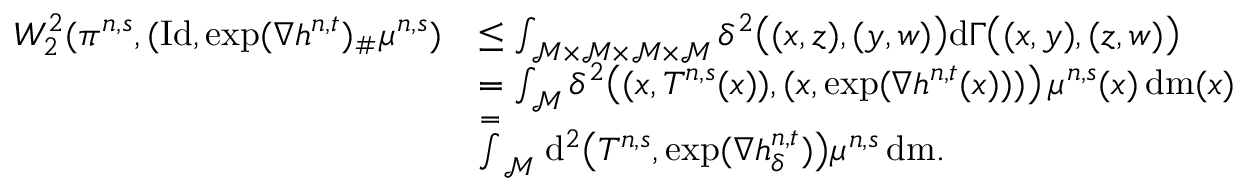<formula> <loc_0><loc_0><loc_500><loc_500>\begin{array} { r l } { W _ { 2 } ^ { 2 } ( \pi ^ { n , s } , ( I d , \exp ( \nabla h ^ { n , t } ) _ { \# } \mu ^ { n , s } ) } & { \leq \int _ { \mathcal { M } \times \mathcal { M } \times \mathcal { M } \times \mathcal { M } } \delta ^ { 2 } \left ( ( x , z ) , ( y , w ) \right ) d \Gamma \left ( ( x , y ) , ( z , w ) \right ) } \\ & { = \int _ { \mathcal { M } } \delta ^ { 2 } \left ( ( x , T ^ { n , s } ( x ) ) , ( x , \exp ( \nabla h ^ { n , t } ( x ) ) ) \right ) \, \mu ^ { n , s } ( x ) \, d m ( x ) } \\ & { \stackrel { = } \int _ { \mathcal { M } } d ^ { 2 } \left ( T ^ { n , s } , \exp ( \nabla h _ { \delta } ^ { n , t } ) \right ) \mu ^ { n , s } \, d m . } \end{array}</formula> 